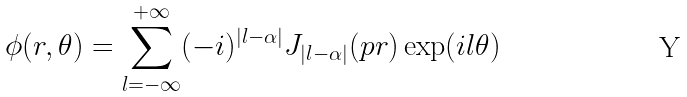Convert formula to latex. <formula><loc_0><loc_0><loc_500><loc_500>\phi ( r , \theta ) = \sum _ { l = - \infty } ^ { + \infty } ( - i ) ^ { | l - \alpha | } J _ { | l - \alpha | } ( p r ) \exp ( i l \theta )</formula> 